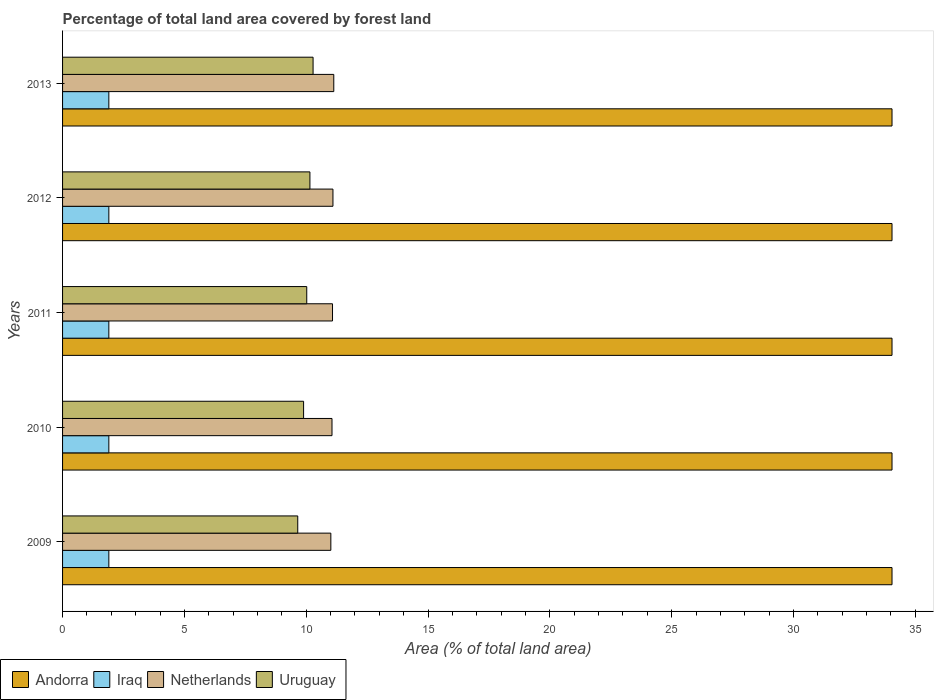How many different coloured bars are there?
Offer a terse response. 4. Are the number of bars on each tick of the Y-axis equal?
Offer a terse response. Yes. How many bars are there on the 1st tick from the bottom?
Offer a very short reply. 4. What is the percentage of forest land in Iraq in 2010?
Provide a short and direct response. 1.9. Across all years, what is the maximum percentage of forest land in Netherlands?
Provide a succinct answer. 11.13. Across all years, what is the minimum percentage of forest land in Uruguay?
Make the answer very short. 9.65. In which year was the percentage of forest land in Netherlands maximum?
Offer a terse response. 2013. In which year was the percentage of forest land in Netherlands minimum?
Provide a succinct answer. 2009. What is the total percentage of forest land in Iraq in the graph?
Give a very brief answer. 9.5. What is the difference between the percentage of forest land in Netherlands in 2011 and the percentage of forest land in Iraq in 2013?
Keep it short and to the point. 9.18. What is the average percentage of forest land in Netherlands per year?
Give a very brief answer. 11.08. In the year 2009, what is the difference between the percentage of forest land in Iraq and percentage of forest land in Netherlands?
Ensure brevity in your answer.  -9.11. In how many years, is the percentage of forest land in Uruguay greater than 26 %?
Your answer should be compact. 0. What is the ratio of the percentage of forest land in Netherlands in 2009 to that in 2010?
Offer a very short reply. 1. Is the difference between the percentage of forest land in Iraq in 2009 and 2013 greater than the difference between the percentage of forest land in Netherlands in 2009 and 2013?
Ensure brevity in your answer.  Yes. What is the difference between the highest and the second highest percentage of forest land in Andorra?
Your answer should be compact. 0. Is the sum of the percentage of forest land in Iraq in 2009 and 2011 greater than the maximum percentage of forest land in Andorra across all years?
Provide a short and direct response. No. Is it the case that in every year, the sum of the percentage of forest land in Uruguay and percentage of forest land in Andorra is greater than the sum of percentage of forest land in Netherlands and percentage of forest land in Iraq?
Your response must be concise. Yes. What does the 2nd bar from the bottom in 2009 represents?
Your answer should be compact. Iraq. How many bars are there?
Make the answer very short. 20. Are all the bars in the graph horizontal?
Offer a very short reply. Yes. How many years are there in the graph?
Keep it short and to the point. 5. Are the values on the major ticks of X-axis written in scientific E-notation?
Ensure brevity in your answer.  No. Does the graph contain grids?
Make the answer very short. No. What is the title of the graph?
Your answer should be very brief. Percentage of total land area covered by forest land. Does "Serbia" appear as one of the legend labels in the graph?
Ensure brevity in your answer.  No. What is the label or title of the X-axis?
Offer a very short reply. Area (% of total land area). What is the Area (% of total land area) in Andorra in 2009?
Provide a succinct answer. 34.04. What is the Area (% of total land area) of Iraq in 2009?
Give a very brief answer. 1.9. What is the Area (% of total land area) in Netherlands in 2009?
Make the answer very short. 11.01. What is the Area (% of total land area) of Uruguay in 2009?
Your answer should be very brief. 9.65. What is the Area (% of total land area) in Andorra in 2010?
Provide a short and direct response. 34.04. What is the Area (% of total land area) of Iraq in 2010?
Your response must be concise. 1.9. What is the Area (% of total land area) in Netherlands in 2010?
Give a very brief answer. 11.06. What is the Area (% of total land area) of Uruguay in 2010?
Keep it short and to the point. 9.89. What is the Area (% of total land area) of Andorra in 2011?
Offer a terse response. 34.04. What is the Area (% of total land area) in Iraq in 2011?
Your answer should be compact. 1.9. What is the Area (% of total land area) of Netherlands in 2011?
Provide a succinct answer. 11.08. What is the Area (% of total land area) of Uruguay in 2011?
Your answer should be compact. 10.02. What is the Area (% of total land area) in Andorra in 2012?
Offer a terse response. 34.04. What is the Area (% of total land area) of Iraq in 2012?
Offer a terse response. 1.9. What is the Area (% of total land area) of Netherlands in 2012?
Offer a terse response. 11.1. What is the Area (% of total land area) in Uruguay in 2012?
Ensure brevity in your answer.  10.15. What is the Area (% of total land area) in Andorra in 2013?
Ensure brevity in your answer.  34.04. What is the Area (% of total land area) of Iraq in 2013?
Provide a succinct answer. 1.9. What is the Area (% of total land area) in Netherlands in 2013?
Provide a succinct answer. 11.13. What is the Area (% of total land area) in Uruguay in 2013?
Your answer should be compact. 10.28. Across all years, what is the maximum Area (% of total land area) in Andorra?
Give a very brief answer. 34.04. Across all years, what is the maximum Area (% of total land area) of Iraq?
Keep it short and to the point. 1.9. Across all years, what is the maximum Area (% of total land area) in Netherlands?
Provide a short and direct response. 11.13. Across all years, what is the maximum Area (% of total land area) of Uruguay?
Provide a succinct answer. 10.28. Across all years, what is the minimum Area (% of total land area) of Andorra?
Give a very brief answer. 34.04. Across all years, what is the minimum Area (% of total land area) in Iraq?
Your answer should be compact. 1.9. Across all years, what is the minimum Area (% of total land area) in Netherlands?
Provide a short and direct response. 11.01. Across all years, what is the minimum Area (% of total land area) of Uruguay?
Ensure brevity in your answer.  9.65. What is the total Area (% of total land area) of Andorra in the graph?
Offer a very short reply. 170.21. What is the total Area (% of total land area) in Iraq in the graph?
Ensure brevity in your answer.  9.5. What is the total Area (% of total land area) of Netherlands in the graph?
Your response must be concise. 55.38. What is the total Area (% of total land area) in Uruguay in the graph?
Keep it short and to the point. 50. What is the difference between the Area (% of total land area) in Iraq in 2009 and that in 2010?
Provide a succinct answer. 0. What is the difference between the Area (% of total land area) of Netherlands in 2009 and that in 2010?
Give a very brief answer. -0.05. What is the difference between the Area (% of total land area) in Uruguay in 2009 and that in 2010?
Give a very brief answer. -0.24. What is the difference between the Area (% of total land area) in Iraq in 2009 and that in 2011?
Offer a terse response. 0. What is the difference between the Area (% of total land area) in Netherlands in 2009 and that in 2011?
Provide a succinct answer. -0.07. What is the difference between the Area (% of total land area) in Uruguay in 2009 and that in 2011?
Keep it short and to the point. -0.37. What is the difference between the Area (% of total land area) of Andorra in 2009 and that in 2012?
Your answer should be very brief. 0. What is the difference between the Area (% of total land area) of Netherlands in 2009 and that in 2012?
Offer a very short reply. -0.09. What is the difference between the Area (% of total land area) in Uruguay in 2009 and that in 2012?
Your answer should be compact. -0.5. What is the difference between the Area (% of total land area) of Iraq in 2009 and that in 2013?
Offer a terse response. 0. What is the difference between the Area (% of total land area) of Netherlands in 2009 and that in 2013?
Keep it short and to the point. -0.12. What is the difference between the Area (% of total land area) of Uruguay in 2009 and that in 2013?
Your answer should be very brief. -0.63. What is the difference between the Area (% of total land area) in Andorra in 2010 and that in 2011?
Offer a terse response. 0. What is the difference between the Area (% of total land area) of Iraq in 2010 and that in 2011?
Offer a very short reply. 0. What is the difference between the Area (% of total land area) in Netherlands in 2010 and that in 2011?
Make the answer very short. -0.02. What is the difference between the Area (% of total land area) in Uruguay in 2010 and that in 2011?
Make the answer very short. -0.13. What is the difference between the Area (% of total land area) in Andorra in 2010 and that in 2012?
Offer a very short reply. 0. What is the difference between the Area (% of total land area) in Netherlands in 2010 and that in 2012?
Offer a very short reply. -0.04. What is the difference between the Area (% of total land area) in Uruguay in 2010 and that in 2012?
Your answer should be very brief. -0.26. What is the difference between the Area (% of total land area) of Netherlands in 2010 and that in 2013?
Give a very brief answer. -0.07. What is the difference between the Area (% of total land area) in Uruguay in 2010 and that in 2013?
Your answer should be compact. -0.39. What is the difference between the Area (% of total land area) in Netherlands in 2011 and that in 2012?
Provide a short and direct response. -0.02. What is the difference between the Area (% of total land area) in Uruguay in 2011 and that in 2012?
Offer a terse response. -0.13. What is the difference between the Area (% of total land area) in Iraq in 2011 and that in 2013?
Your response must be concise. 0. What is the difference between the Area (% of total land area) in Netherlands in 2011 and that in 2013?
Your answer should be compact. -0.05. What is the difference between the Area (% of total land area) in Uruguay in 2011 and that in 2013?
Give a very brief answer. -0.26. What is the difference between the Area (% of total land area) in Andorra in 2012 and that in 2013?
Provide a short and direct response. 0. What is the difference between the Area (% of total land area) of Iraq in 2012 and that in 2013?
Your answer should be very brief. 0. What is the difference between the Area (% of total land area) in Netherlands in 2012 and that in 2013?
Your answer should be compact. -0.03. What is the difference between the Area (% of total land area) of Uruguay in 2012 and that in 2013?
Your answer should be very brief. -0.13. What is the difference between the Area (% of total land area) of Andorra in 2009 and the Area (% of total land area) of Iraq in 2010?
Your answer should be compact. 32.14. What is the difference between the Area (% of total land area) in Andorra in 2009 and the Area (% of total land area) in Netherlands in 2010?
Give a very brief answer. 22.98. What is the difference between the Area (% of total land area) of Andorra in 2009 and the Area (% of total land area) of Uruguay in 2010?
Offer a terse response. 24.15. What is the difference between the Area (% of total land area) of Iraq in 2009 and the Area (% of total land area) of Netherlands in 2010?
Your response must be concise. -9.16. What is the difference between the Area (% of total land area) of Iraq in 2009 and the Area (% of total land area) of Uruguay in 2010?
Give a very brief answer. -7.99. What is the difference between the Area (% of total land area) of Netherlands in 2009 and the Area (% of total land area) of Uruguay in 2010?
Give a very brief answer. 1.12. What is the difference between the Area (% of total land area) of Andorra in 2009 and the Area (% of total land area) of Iraq in 2011?
Ensure brevity in your answer.  32.14. What is the difference between the Area (% of total land area) of Andorra in 2009 and the Area (% of total land area) of Netherlands in 2011?
Your answer should be very brief. 22.96. What is the difference between the Area (% of total land area) in Andorra in 2009 and the Area (% of total land area) in Uruguay in 2011?
Offer a very short reply. 24.02. What is the difference between the Area (% of total land area) of Iraq in 2009 and the Area (% of total land area) of Netherlands in 2011?
Your response must be concise. -9.18. What is the difference between the Area (% of total land area) of Iraq in 2009 and the Area (% of total land area) of Uruguay in 2011?
Provide a short and direct response. -8.12. What is the difference between the Area (% of total land area) of Andorra in 2009 and the Area (% of total land area) of Iraq in 2012?
Provide a succinct answer. 32.14. What is the difference between the Area (% of total land area) of Andorra in 2009 and the Area (% of total land area) of Netherlands in 2012?
Provide a short and direct response. 22.95. What is the difference between the Area (% of total land area) in Andorra in 2009 and the Area (% of total land area) in Uruguay in 2012?
Offer a terse response. 23.89. What is the difference between the Area (% of total land area) of Iraq in 2009 and the Area (% of total land area) of Netherlands in 2012?
Offer a terse response. -9.2. What is the difference between the Area (% of total land area) of Iraq in 2009 and the Area (% of total land area) of Uruguay in 2012?
Give a very brief answer. -8.25. What is the difference between the Area (% of total land area) of Netherlands in 2009 and the Area (% of total land area) of Uruguay in 2012?
Your answer should be compact. 0.86. What is the difference between the Area (% of total land area) in Andorra in 2009 and the Area (% of total land area) in Iraq in 2013?
Ensure brevity in your answer.  32.14. What is the difference between the Area (% of total land area) in Andorra in 2009 and the Area (% of total land area) in Netherlands in 2013?
Ensure brevity in your answer.  22.91. What is the difference between the Area (% of total land area) in Andorra in 2009 and the Area (% of total land area) in Uruguay in 2013?
Ensure brevity in your answer.  23.76. What is the difference between the Area (% of total land area) of Iraq in 2009 and the Area (% of total land area) of Netherlands in 2013?
Give a very brief answer. -9.23. What is the difference between the Area (% of total land area) in Iraq in 2009 and the Area (% of total land area) in Uruguay in 2013?
Provide a succinct answer. -8.38. What is the difference between the Area (% of total land area) in Netherlands in 2009 and the Area (% of total land area) in Uruguay in 2013?
Your answer should be very brief. 0.73. What is the difference between the Area (% of total land area) in Andorra in 2010 and the Area (% of total land area) in Iraq in 2011?
Ensure brevity in your answer.  32.14. What is the difference between the Area (% of total land area) of Andorra in 2010 and the Area (% of total land area) of Netherlands in 2011?
Your answer should be compact. 22.96. What is the difference between the Area (% of total land area) of Andorra in 2010 and the Area (% of total land area) of Uruguay in 2011?
Your response must be concise. 24.02. What is the difference between the Area (% of total land area) of Iraq in 2010 and the Area (% of total land area) of Netherlands in 2011?
Make the answer very short. -9.18. What is the difference between the Area (% of total land area) of Iraq in 2010 and the Area (% of total land area) of Uruguay in 2011?
Give a very brief answer. -8.12. What is the difference between the Area (% of total land area) in Netherlands in 2010 and the Area (% of total land area) in Uruguay in 2011?
Ensure brevity in your answer.  1.04. What is the difference between the Area (% of total land area) in Andorra in 2010 and the Area (% of total land area) in Iraq in 2012?
Keep it short and to the point. 32.14. What is the difference between the Area (% of total land area) in Andorra in 2010 and the Area (% of total land area) in Netherlands in 2012?
Ensure brevity in your answer.  22.95. What is the difference between the Area (% of total land area) in Andorra in 2010 and the Area (% of total land area) in Uruguay in 2012?
Provide a short and direct response. 23.89. What is the difference between the Area (% of total land area) in Iraq in 2010 and the Area (% of total land area) in Netherlands in 2012?
Ensure brevity in your answer.  -9.2. What is the difference between the Area (% of total land area) of Iraq in 2010 and the Area (% of total land area) of Uruguay in 2012?
Give a very brief answer. -8.25. What is the difference between the Area (% of total land area) in Netherlands in 2010 and the Area (% of total land area) in Uruguay in 2012?
Your answer should be compact. 0.91. What is the difference between the Area (% of total land area) in Andorra in 2010 and the Area (% of total land area) in Iraq in 2013?
Your answer should be compact. 32.14. What is the difference between the Area (% of total land area) in Andorra in 2010 and the Area (% of total land area) in Netherlands in 2013?
Keep it short and to the point. 22.91. What is the difference between the Area (% of total land area) in Andorra in 2010 and the Area (% of total land area) in Uruguay in 2013?
Make the answer very short. 23.76. What is the difference between the Area (% of total land area) in Iraq in 2010 and the Area (% of total land area) in Netherlands in 2013?
Your answer should be very brief. -9.23. What is the difference between the Area (% of total land area) in Iraq in 2010 and the Area (% of total land area) in Uruguay in 2013?
Your answer should be very brief. -8.38. What is the difference between the Area (% of total land area) of Netherlands in 2010 and the Area (% of total land area) of Uruguay in 2013?
Your answer should be compact. 0.78. What is the difference between the Area (% of total land area) of Andorra in 2011 and the Area (% of total land area) of Iraq in 2012?
Your answer should be compact. 32.14. What is the difference between the Area (% of total land area) of Andorra in 2011 and the Area (% of total land area) of Netherlands in 2012?
Provide a succinct answer. 22.95. What is the difference between the Area (% of total land area) in Andorra in 2011 and the Area (% of total land area) in Uruguay in 2012?
Offer a very short reply. 23.89. What is the difference between the Area (% of total land area) of Iraq in 2011 and the Area (% of total land area) of Netherlands in 2012?
Give a very brief answer. -9.2. What is the difference between the Area (% of total land area) of Iraq in 2011 and the Area (% of total land area) of Uruguay in 2012?
Keep it short and to the point. -8.25. What is the difference between the Area (% of total land area) of Netherlands in 2011 and the Area (% of total land area) of Uruguay in 2012?
Ensure brevity in your answer.  0.93. What is the difference between the Area (% of total land area) in Andorra in 2011 and the Area (% of total land area) in Iraq in 2013?
Provide a succinct answer. 32.14. What is the difference between the Area (% of total land area) of Andorra in 2011 and the Area (% of total land area) of Netherlands in 2013?
Offer a very short reply. 22.91. What is the difference between the Area (% of total land area) of Andorra in 2011 and the Area (% of total land area) of Uruguay in 2013?
Offer a terse response. 23.76. What is the difference between the Area (% of total land area) of Iraq in 2011 and the Area (% of total land area) of Netherlands in 2013?
Offer a very short reply. -9.23. What is the difference between the Area (% of total land area) of Iraq in 2011 and the Area (% of total land area) of Uruguay in 2013?
Ensure brevity in your answer.  -8.38. What is the difference between the Area (% of total land area) in Netherlands in 2011 and the Area (% of total land area) in Uruguay in 2013?
Provide a succinct answer. 0.8. What is the difference between the Area (% of total land area) in Andorra in 2012 and the Area (% of total land area) in Iraq in 2013?
Give a very brief answer. 32.14. What is the difference between the Area (% of total land area) of Andorra in 2012 and the Area (% of total land area) of Netherlands in 2013?
Your response must be concise. 22.91. What is the difference between the Area (% of total land area) in Andorra in 2012 and the Area (% of total land area) in Uruguay in 2013?
Provide a succinct answer. 23.76. What is the difference between the Area (% of total land area) of Iraq in 2012 and the Area (% of total land area) of Netherlands in 2013?
Provide a short and direct response. -9.23. What is the difference between the Area (% of total land area) of Iraq in 2012 and the Area (% of total land area) of Uruguay in 2013?
Give a very brief answer. -8.38. What is the difference between the Area (% of total land area) of Netherlands in 2012 and the Area (% of total land area) of Uruguay in 2013?
Your answer should be compact. 0.82. What is the average Area (% of total land area) in Andorra per year?
Offer a very short reply. 34.04. What is the average Area (% of total land area) in Iraq per year?
Provide a succinct answer. 1.9. What is the average Area (% of total land area) of Netherlands per year?
Give a very brief answer. 11.08. What is the average Area (% of total land area) of Uruguay per year?
Your answer should be very brief. 10. In the year 2009, what is the difference between the Area (% of total land area) in Andorra and Area (% of total land area) in Iraq?
Keep it short and to the point. 32.14. In the year 2009, what is the difference between the Area (% of total land area) of Andorra and Area (% of total land area) of Netherlands?
Ensure brevity in your answer.  23.03. In the year 2009, what is the difference between the Area (% of total land area) of Andorra and Area (% of total land area) of Uruguay?
Your answer should be compact. 24.39. In the year 2009, what is the difference between the Area (% of total land area) of Iraq and Area (% of total land area) of Netherlands?
Give a very brief answer. -9.11. In the year 2009, what is the difference between the Area (% of total land area) of Iraq and Area (% of total land area) of Uruguay?
Your response must be concise. -7.75. In the year 2009, what is the difference between the Area (% of total land area) in Netherlands and Area (% of total land area) in Uruguay?
Give a very brief answer. 1.36. In the year 2010, what is the difference between the Area (% of total land area) in Andorra and Area (% of total land area) in Iraq?
Provide a short and direct response. 32.14. In the year 2010, what is the difference between the Area (% of total land area) of Andorra and Area (% of total land area) of Netherlands?
Your answer should be very brief. 22.98. In the year 2010, what is the difference between the Area (% of total land area) of Andorra and Area (% of total land area) of Uruguay?
Give a very brief answer. 24.15. In the year 2010, what is the difference between the Area (% of total land area) in Iraq and Area (% of total land area) in Netherlands?
Your response must be concise. -9.16. In the year 2010, what is the difference between the Area (% of total land area) in Iraq and Area (% of total land area) in Uruguay?
Your answer should be very brief. -7.99. In the year 2010, what is the difference between the Area (% of total land area) in Netherlands and Area (% of total land area) in Uruguay?
Your answer should be compact. 1.17. In the year 2011, what is the difference between the Area (% of total land area) of Andorra and Area (% of total land area) of Iraq?
Give a very brief answer. 32.14. In the year 2011, what is the difference between the Area (% of total land area) in Andorra and Area (% of total land area) in Netherlands?
Your answer should be compact. 22.96. In the year 2011, what is the difference between the Area (% of total land area) of Andorra and Area (% of total land area) of Uruguay?
Keep it short and to the point. 24.02. In the year 2011, what is the difference between the Area (% of total land area) of Iraq and Area (% of total land area) of Netherlands?
Your answer should be compact. -9.18. In the year 2011, what is the difference between the Area (% of total land area) in Iraq and Area (% of total land area) in Uruguay?
Provide a short and direct response. -8.12. In the year 2011, what is the difference between the Area (% of total land area) of Netherlands and Area (% of total land area) of Uruguay?
Make the answer very short. 1.06. In the year 2012, what is the difference between the Area (% of total land area) of Andorra and Area (% of total land area) of Iraq?
Provide a succinct answer. 32.14. In the year 2012, what is the difference between the Area (% of total land area) in Andorra and Area (% of total land area) in Netherlands?
Provide a succinct answer. 22.95. In the year 2012, what is the difference between the Area (% of total land area) in Andorra and Area (% of total land area) in Uruguay?
Provide a short and direct response. 23.89. In the year 2012, what is the difference between the Area (% of total land area) in Iraq and Area (% of total land area) in Netherlands?
Provide a short and direct response. -9.2. In the year 2012, what is the difference between the Area (% of total land area) of Iraq and Area (% of total land area) of Uruguay?
Your answer should be very brief. -8.25. In the year 2012, what is the difference between the Area (% of total land area) in Netherlands and Area (% of total land area) in Uruguay?
Provide a short and direct response. 0.95. In the year 2013, what is the difference between the Area (% of total land area) of Andorra and Area (% of total land area) of Iraq?
Offer a very short reply. 32.14. In the year 2013, what is the difference between the Area (% of total land area) of Andorra and Area (% of total land area) of Netherlands?
Provide a short and direct response. 22.91. In the year 2013, what is the difference between the Area (% of total land area) of Andorra and Area (% of total land area) of Uruguay?
Make the answer very short. 23.76. In the year 2013, what is the difference between the Area (% of total land area) of Iraq and Area (% of total land area) of Netherlands?
Your answer should be very brief. -9.23. In the year 2013, what is the difference between the Area (% of total land area) of Iraq and Area (% of total land area) of Uruguay?
Give a very brief answer. -8.38. In the year 2013, what is the difference between the Area (% of total land area) of Netherlands and Area (% of total land area) of Uruguay?
Offer a very short reply. 0.85. What is the ratio of the Area (% of total land area) of Andorra in 2009 to that in 2010?
Make the answer very short. 1. What is the ratio of the Area (% of total land area) of Iraq in 2009 to that in 2010?
Your answer should be very brief. 1. What is the ratio of the Area (% of total land area) in Uruguay in 2009 to that in 2010?
Give a very brief answer. 0.98. What is the ratio of the Area (% of total land area) in Andorra in 2009 to that in 2011?
Offer a terse response. 1. What is the ratio of the Area (% of total land area) in Netherlands in 2009 to that in 2011?
Make the answer very short. 0.99. What is the ratio of the Area (% of total land area) in Uruguay in 2009 to that in 2011?
Give a very brief answer. 0.96. What is the ratio of the Area (% of total land area) in Netherlands in 2009 to that in 2012?
Give a very brief answer. 0.99. What is the ratio of the Area (% of total land area) of Uruguay in 2009 to that in 2012?
Give a very brief answer. 0.95. What is the ratio of the Area (% of total land area) in Andorra in 2009 to that in 2013?
Offer a very short reply. 1. What is the ratio of the Area (% of total land area) of Netherlands in 2009 to that in 2013?
Keep it short and to the point. 0.99. What is the ratio of the Area (% of total land area) in Uruguay in 2009 to that in 2013?
Keep it short and to the point. 0.94. What is the ratio of the Area (% of total land area) in Uruguay in 2010 to that in 2011?
Keep it short and to the point. 0.99. What is the ratio of the Area (% of total land area) in Andorra in 2010 to that in 2012?
Ensure brevity in your answer.  1. What is the ratio of the Area (% of total land area) in Uruguay in 2010 to that in 2012?
Ensure brevity in your answer.  0.97. What is the ratio of the Area (% of total land area) in Andorra in 2010 to that in 2013?
Your answer should be compact. 1. What is the ratio of the Area (% of total land area) of Uruguay in 2010 to that in 2013?
Your answer should be very brief. 0.96. What is the ratio of the Area (% of total land area) in Iraq in 2011 to that in 2012?
Offer a very short reply. 1. What is the ratio of the Area (% of total land area) of Netherlands in 2011 to that in 2012?
Provide a succinct answer. 1. What is the ratio of the Area (% of total land area) of Uruguay in 2011 to that in 2012?
Your response must be concise. 0.99. What is the ratio of the Area (% of total land area) of Andorra in 2011 to that in 2013?
Your answer should be very brief. 1. What is the ratio of the Area (% of total land area) of Uruguay in 2011 to that in 2013?
Your answer should be very brief. 0.97. What is the ratio of the Area (% of total land area) of Netherlands in 2012 to that in 2013?
Offer a terse response. 1. What is the ratio of the Area (% of total land area) in Uruguay in 2012 to that in 2013?
Offer a very short reply. 0.99. What is the difference between the highest and the second highest Area (% of total land area) in Netherlands?
Give a very brief answer. 0.03. What is the difference between the highest and the second highest Area (% of total land area) in Uruguay?
Give a very brief answer. 0.13. What is the difference between the highest and the lowest Area (% of total land area) of Andorra?
Give a very brief answer. 0. What is the difference between the highest and the lowest Area (% of total land area) of Iraq?
Your response must be concise. 0. What is the difference between the highest and the lowest Area (% of total land area) of Netherlands?
Your answer should be very brief. 0.12. What is the difference between the highest and the lowest Area (% of total land area) in Uruguay?
Give a very brief answer. 0.63. 